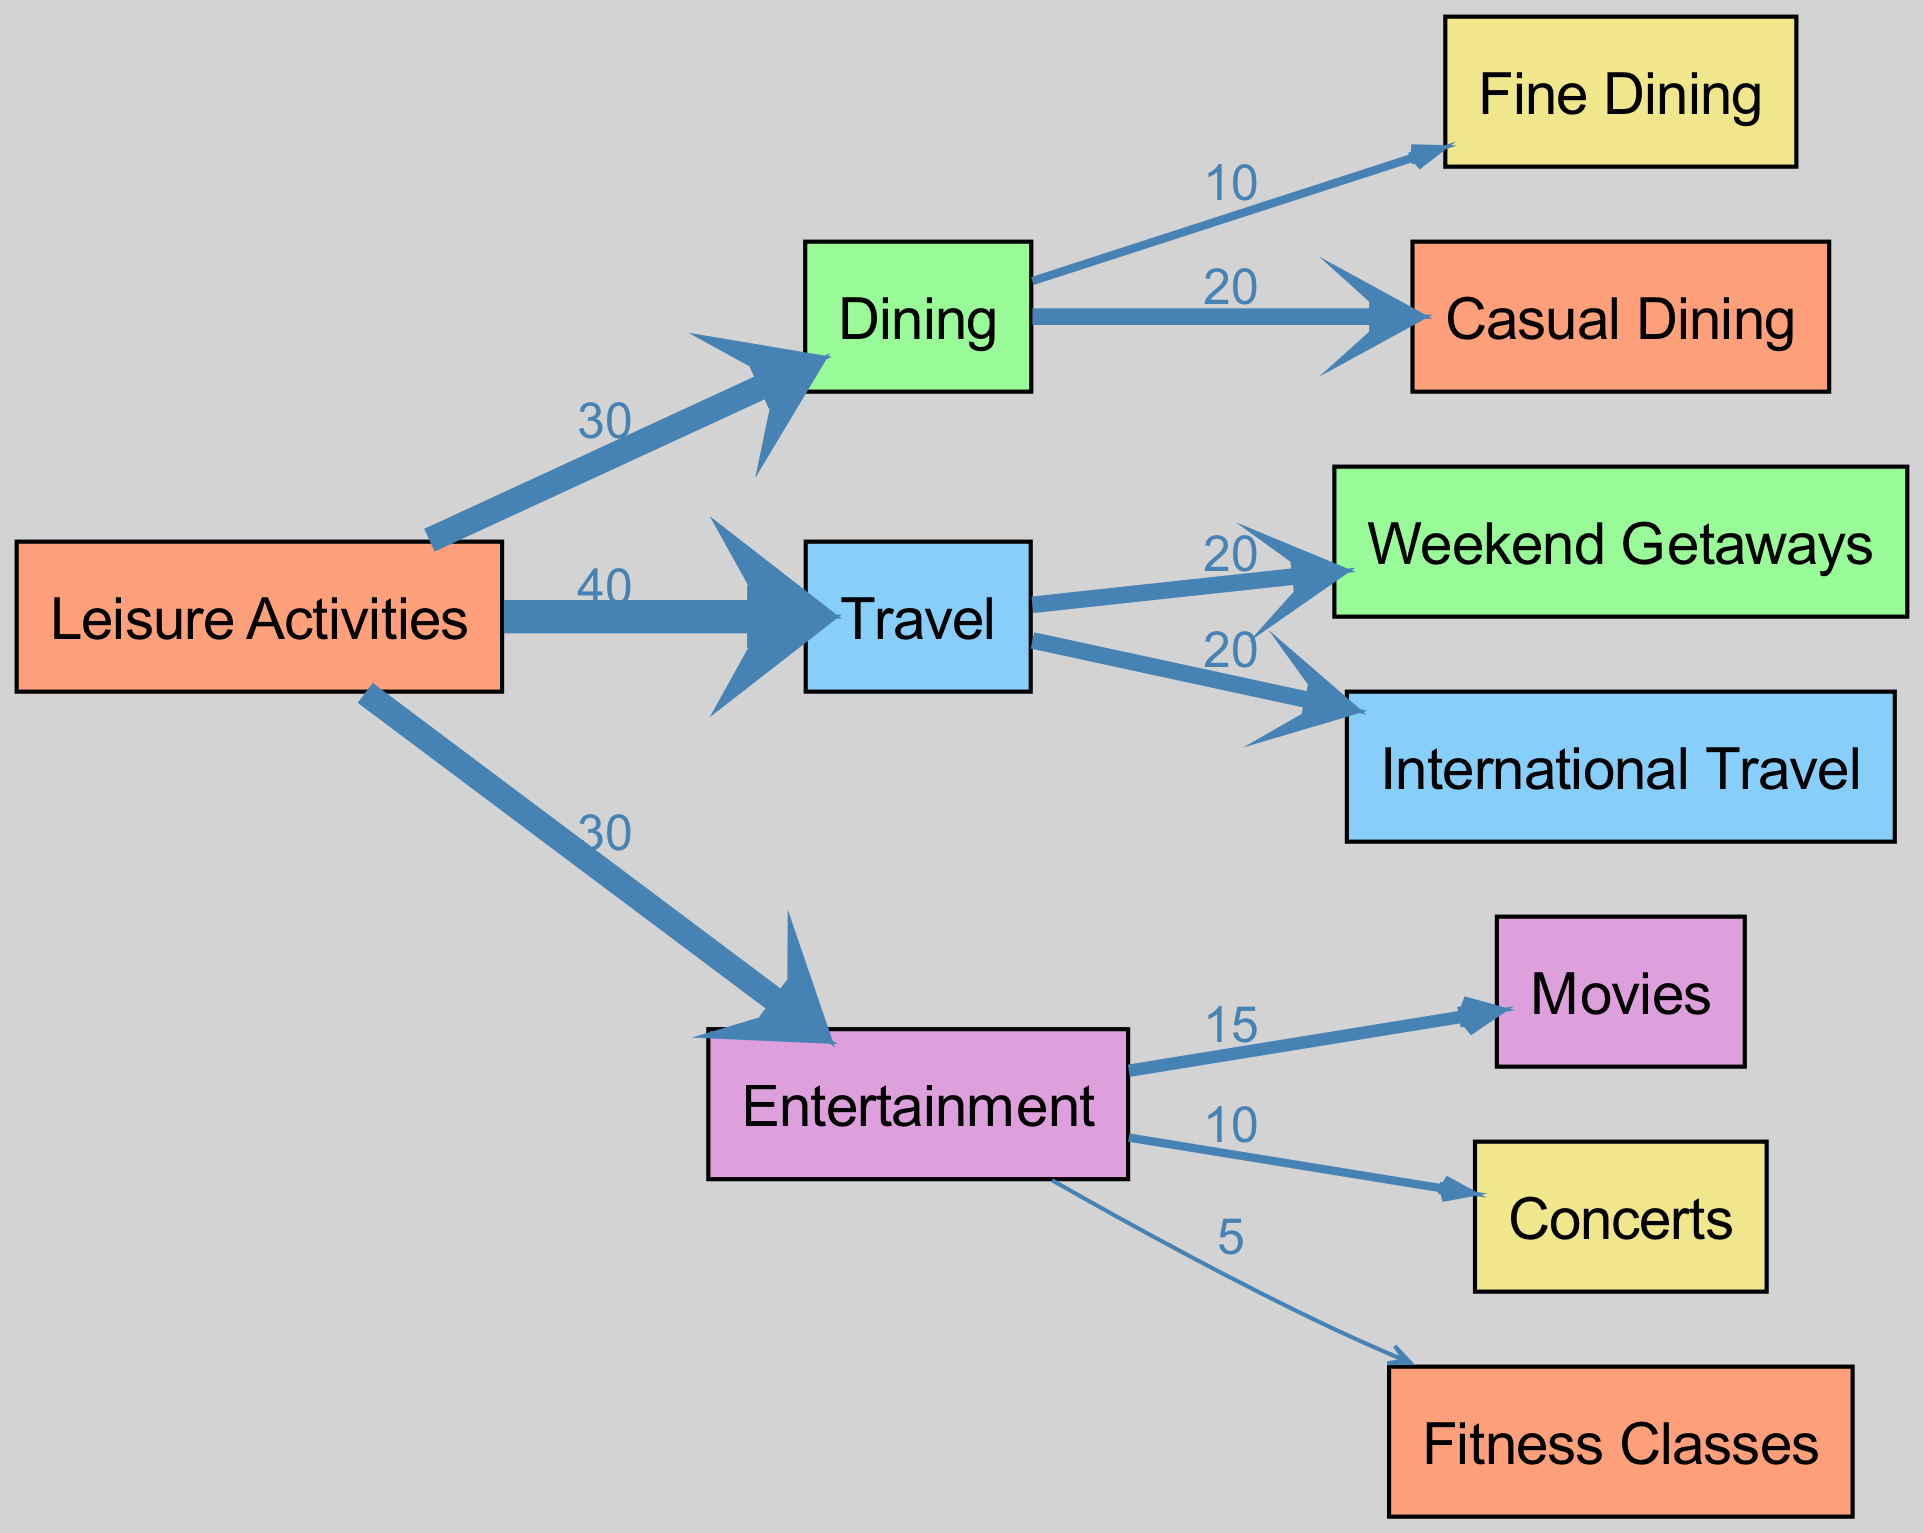What is the total budget distribution for Leisure Activities? The diagram shows three main categories under Leisure Activities: Dining (30), Travel (40), and Entertainment (30). To find the total budget, sum these values: 30 + 40 + 30 = 100.
Answer: 100 How much budget is allocated to International Travel? Looking at the link between Travel and InternationalTravel, the diagram shows a value of 20.
Answer: 20 Which category has the highest budget allocation? The budget allocations are as follows: Dining (30), Travel (40), and Entertainment (30). The highest value is 40, pertaining to the Travel category.
Answer: Travel What percentage of the total budget is spent on Casual Dining? Casual Dining is allocated 20 out of the total budget of 100. To find the percentage, calculate (20/100) * 100 = 20%.
Answer: 20% How many edges are connected to the Entertainment node? The Entertainment node connects to three activities: Movies, Concerts, and Fitness Classes. Therefore, there are three edges connected to this node.
Answer: 3 What is the relationship between Fitness Classes and Leisure Activities? Fitness Classes is categorized under Entertainment, which is one of the three main categories under Leisure Activities. The flow indicates that some budget from Entertainment (5) goes into Fitness Classes.
Answer: Indirect Which leisure activity category has the least budgetary allocation? The diagram indicates that Fitness Classes, associated with the Entertainment category, has the smallest allocation of 5.
Answer: Fitness Classes What is the total budget allocated to Travel activities? The Travel category is divided into two segments: Weekend Getaways (20) and International Travel (20). Adding these gives a total of 20 + 20 = 40.
Answer: 40 Which dining option receives the majority of the budget? Under the Dining category, Fine Dining is allocated 10 and Casual Dining is allocated 20. Since 20 is greater than 10, Casual Dining receives the majority.
Answer: Casual Dining 